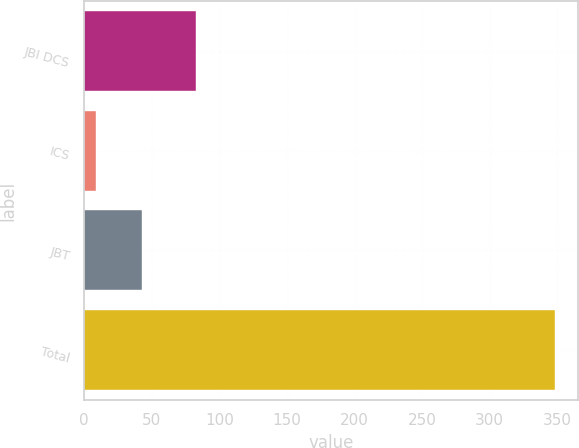Convert chart to OTSL. <chart><loc_0><loc_0><loc_500><loc_500><bar_chart><fcel>JBI DCS<fcel>ICS<fcel>JBT<fcel>Total<nl><fcel>83<fcel>9<fcel>42.9<fcel>348<nl></chart> 